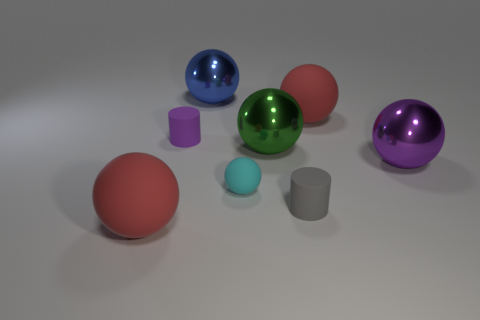How big is the blue metallic thing?
Your answer should be compact. Large. Are there any large green shiny objects of the same shape as the tiny purple object?
Ensure brevity in your answer.  No. How many things are either red matte things or big matte objects that are on the left side of the green thing?
Your answer should be very brief. 2. The small rubber cylinder that is behind the cyan rubber ball is what color?
Keep it short and to the point. Purple. There is a red object on the left side of the gray cylinder; does it have the same size as the red matte sphere that is behind the small gray cylinder?
Ensure brevity in your answer.  Yes. Are there any cyan matte objects of the same size as the cyan matte ball?
Your answer should be compact. No. There is a big red matte object that is behind the cyan rubber ball; what number of purple spheres are behind it?
Make the answer very short. 0. What material is the cyan object?
Offer a terse response. Rubber. How many tiny matte things are in front of the tiny gray matte cylinder?
Offer a terse response. 0. What number of things are the same color as the small rubber sphere?
Offer a terse response. 0. 